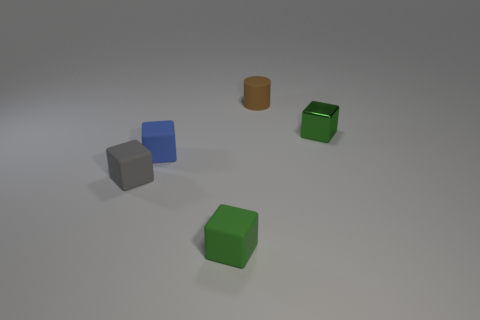Describe the layout and positioning of the objects. The objects are spaced apart on a neutral surface with a light source casting gentle shadows. The two green cubes are positioned closer to each other compred to their distance from the blue cube and the orange cylinder, which are placed further apart from each other and from the green cubes. 